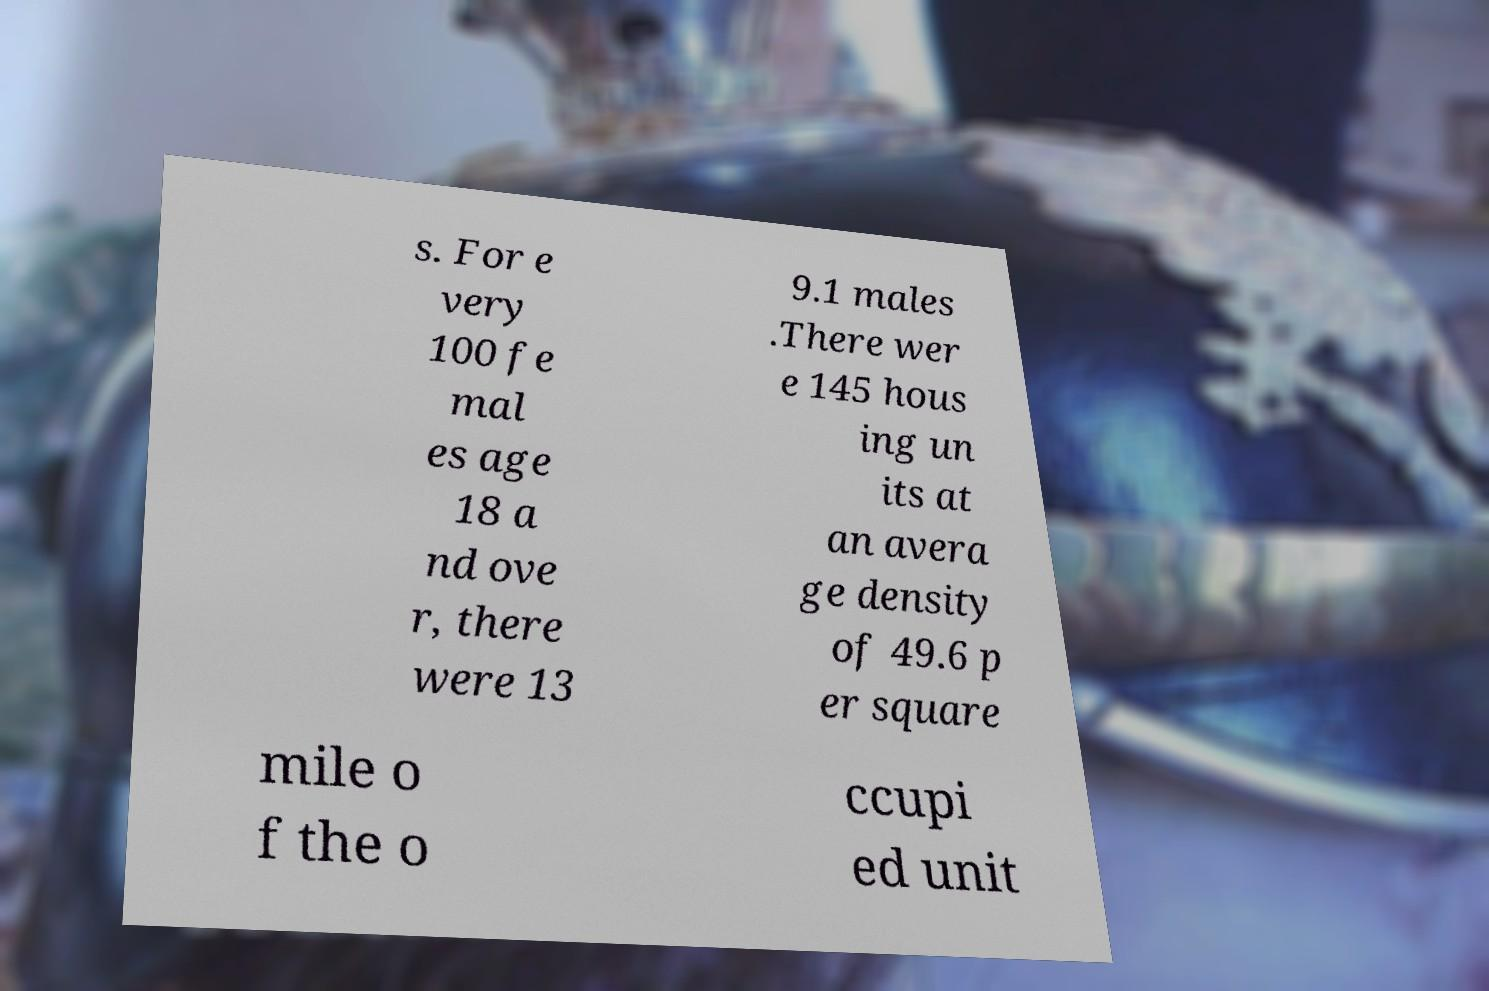I need the written content from this picture converted into text. Can you do that? s. For e very 100 fe mal es age 18 a nd ove r, there were 13 9.1 males .There wer e 145 hous ing un its at an avera ge density of 49.6 p er square mile o f the o ccupi ed unit 